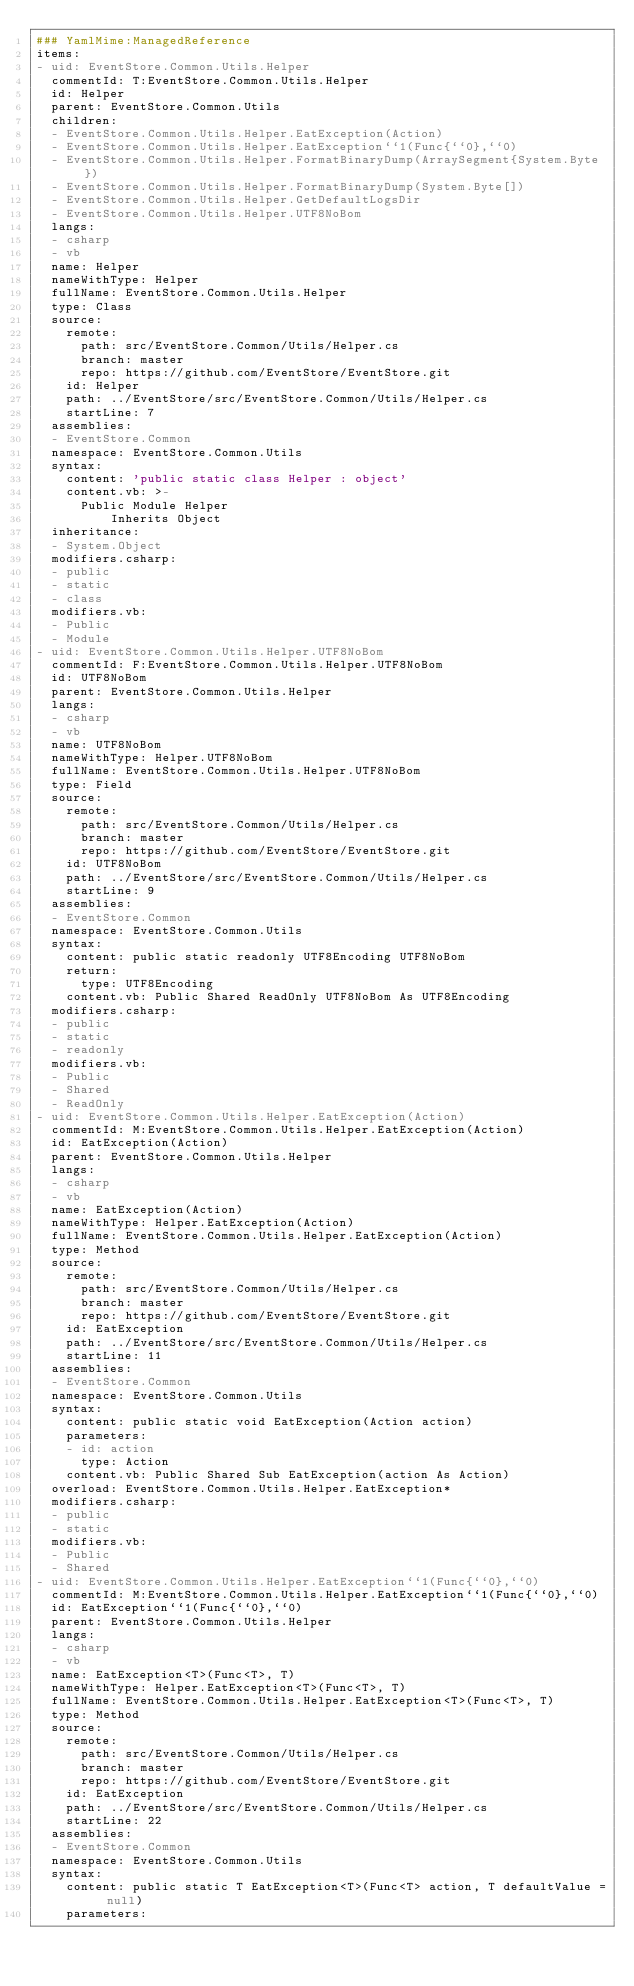<code> <loc_0><loc_0><loc_500><loc_500><_YAML_>### YamlMime:ManagedReference
items:
- uid: EventStore.Common.Utils.Helper
  commentId: T:EventStore.Common.Utils.Helper
  id: Helper
  parent: EventStore.Common.Utils
  children:
  - EventStore.Common.Utils.Helper.EatException(Action)
  - EventStore.Common.Utils.Helper.EatException``1(Func{``0},``0)
  - EventStore.Common.Utils.Helper.FormatBinaryDump(ArraySegment{System.Byte})
  - EventStore.Common.Utils.Helper.FormatBinaryDump(System.Byte[])
  - EventStore.Common.Utils.Helper.GetDefaultLogsDir
  - EventStore.Common.Utils.Helper.UTF8NoBom
  langs:
  - csharp
  - vb
  name: Helper
  nameWithType: Helper
  fullName: EventStore.Common.Utils.Helper
  type: Class
  source:
    remote:
      path: src/EventStore.Common/Utils/Helper.cs
      branch: master
      repo: https://github.com/EventStore/EventStore.git
    id: Helper
    path: ../EventStore/src/EventStore.Common/Utils/Helper.cs
    startLine: 7
  assemblies:
  - EventStore.Common
  namespace: EventStore.Common.Utils
  syntax:
    content: 'public static class Helper : object'
    content.vb: >-
      Public Module Helper
          Inherits Object
  inheritance:
  - System.Object
  modifiers.csharp:
  - public
  - static
  - class
  modifiers.vb:
  - Public
  - Module
- uid: EventStore.Common.Utils.Helper.UTF8NoBom
  commentId: F:EventStore.Common.Utils.Helper.UTF8NoBom
  id: UTF8NoBom
  parent: EventStore.Common.Utils.Helper
  langs:
  - csharp
  - vb
  name: UTF8NoBom
  nameWithType: Helper.UTF8NoBom
  fullName: EventStore.Common.Utils.Helper.UTF8NoBom
  type: Field
  source:
    remote:
      path: src/EventStore.Common/Utils/Helper.cs
      branch: master
      repo: https://github.com/EventStore/EventStore.git
    id: UTF8NoBom
    path: ../EventStore/src/EventStore.Common/Utils/Helper.cs
    startLine: 9
  assemblies:
  - EventStore.Common
  namespace: EventStore.Common.Utils
  syntax:
    content: public static readonly UTF8Encoding UTF8NoBom
    return:
      type: UTF8Encoding
    content.vb: Public Shared ReadOnly UTF8NoBom As UTF8Encoding
  modifiers.csharp:
  - public
  - static
  - readonly
  modifiers.vb:
  - Public
  - Shared
  - ReadOnly
- uid: EventStore.Common.Utils.Helper.EatException(Action)
  commentId: M:EventStore.Common.Utils.Helper.EatException(Action)
  id: EatException(Action)
  parent: EventStore.Common.Utils.Helper
  langs:
  - csharp
  - vb
  name: EatException(Action)
  nameWithType: Helper.EatException(Action)
  fullName: EventStore.Common.Utils.Helper.EatException(Action)
  type: Method
  source:
    remote:
      path: src/EventStore.Common/Utils/Helper.cs
      branch: master
      repo: https://github.com/EventStore/EventStore.git
    id: EatException
    path: ../EventStore/src/EventStore.Common/Utils/Helper.cs
    startLine: 11
  assemblies:
  - EventStore.Common
  namespace: EventStore.Common.Utils
  syntax:
    content: public static void EatException(Action action)
    parameters:
    - id: action
      type: Action
    content.vb: Public Shared Sub EatException(action As Action)
  overload: EventStore.Common.Utils.Helper.EatException*
  modifiers.csharp:
  - public
  - static
  modifiers.vb:
  - Public
  - Shared
- uid: EventStore.Common.Utils.Helper.EatException``1(Func{``0},``0)
  commentId: M:EventStore.Common.Utils.Helper.EatException``1(Func{``0},``0)
  id: EatException``1(Func{``0},``0)
  parent: EventStore.Common.Utils.Helper
  langs:
  - csharp
  - vb
  name: EatException<T>(Func<T>, T)
  nameWithType: Helper.EatException<T>(Func<T>, T)
  fullName: EventStore.Common.Utils.Helper.EatException<T>(Func<T>, T)
  type: Method
  source:
    remote:
      path: src/EventStore.Common/Utils/Helper.cs
      branch: master
      repo: https://github.com/EventStore/EventStore.git
    id: EatException
    path: ../EventStore/src/EventStore.Common/Utils/Helper.cs
    startLine: 22
  assemblies:
  - EventStore.Common
  namespace: EventStore.Common.Utils
  syntax:
    content: public static T EatException<T>(Func<T> action, T defaultValue = null)
    parameters:</code> 